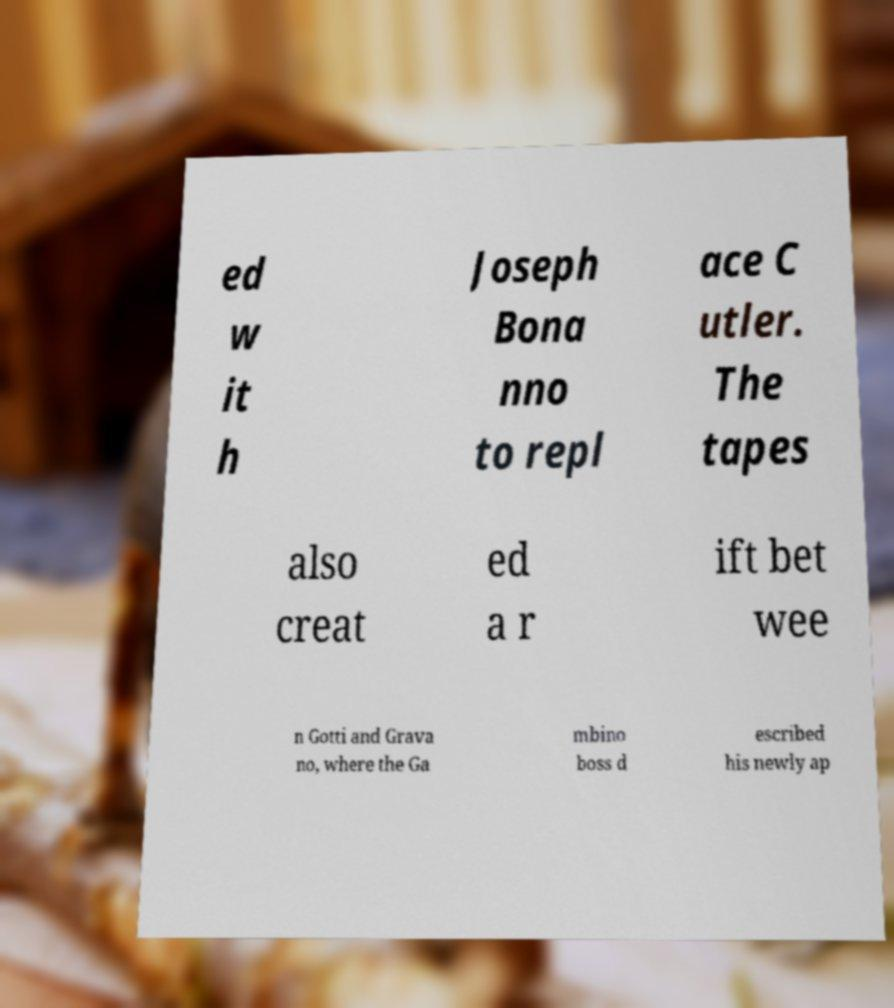Can you read and provide the text displayed in the image?This photo seems to have some interesting text. Can you extract and type it out for me? ed w it h Joseph Bona nno to repl ace C utler. The tapes also creat ed a r ift bet wee n Gotti and Grava no, where the Ga mbino boss d escribed his newly ap 